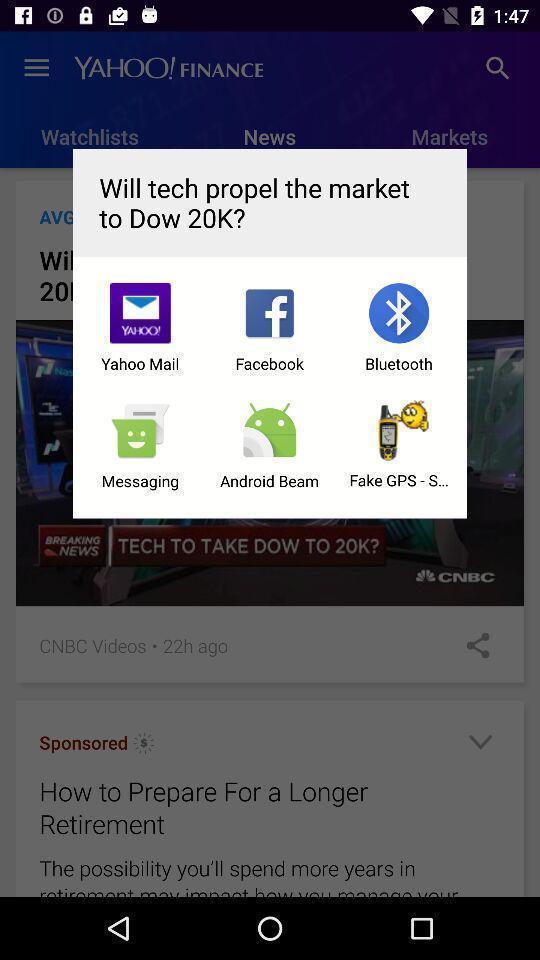Provide a description of this screenshot. Popup showing of different apps. 